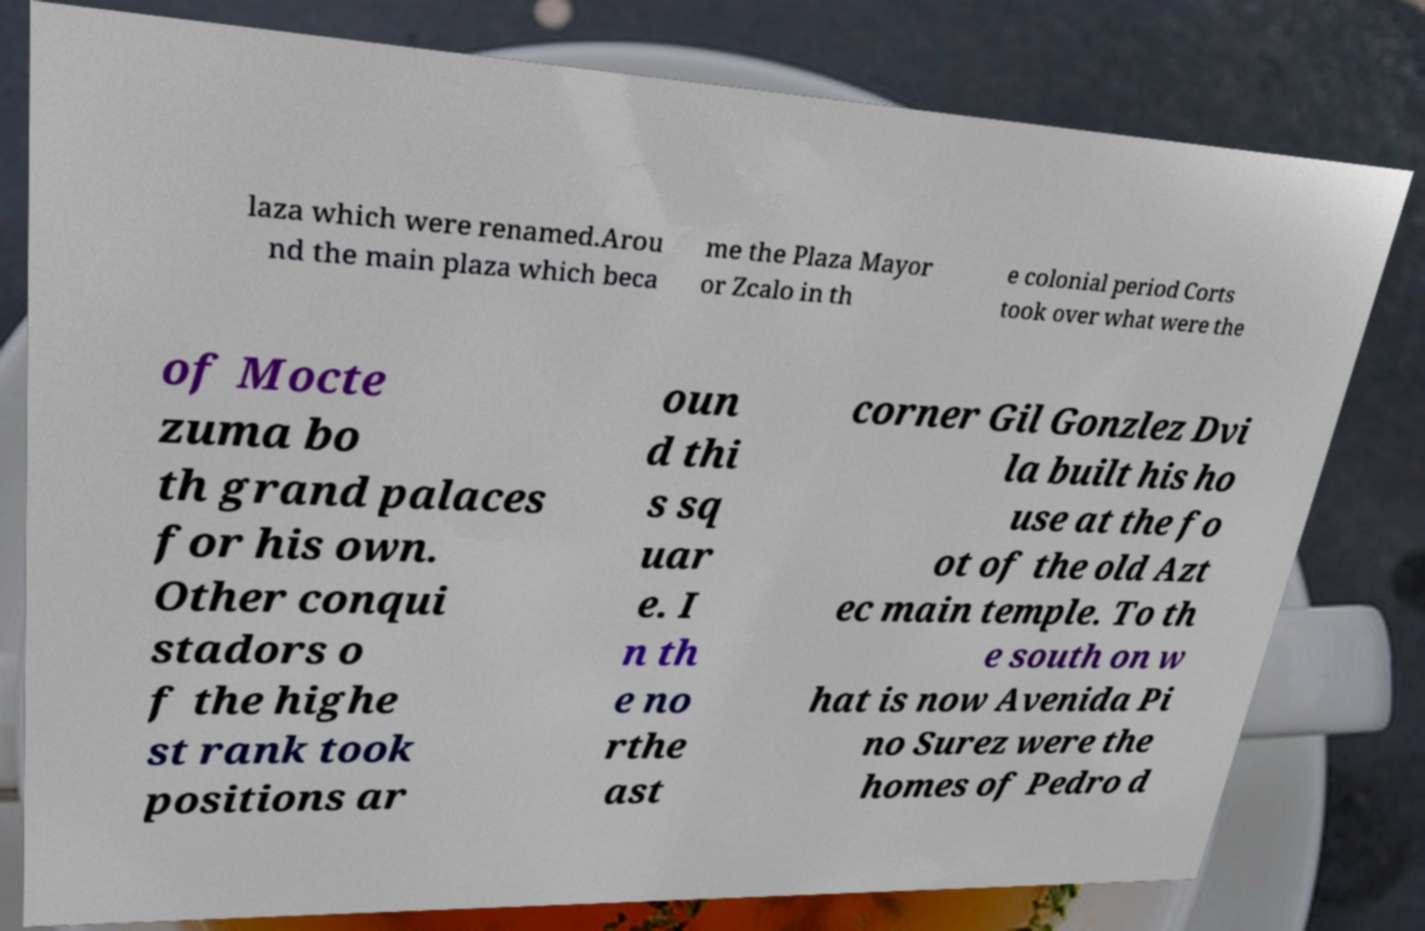Please read and relay the text visible in this image. What does it say? laza which were renamed.Arou nd the main plaza which beca me the Plaza Mayor or Zcalo in th e colonial period Corts took over what were the of Mocte zuma bo th grand palaces for his own. Other conqui stadors o f the highe st rank took positions ar oun d thi s sq uar e. I n th e no rthe ast corner Gil Gonzlez Dvi la built his ho use at the fo ot of the old Azt ec main temple. To th e south on w hat is now Avenida Pi no Surez were the homes of Pedro d 